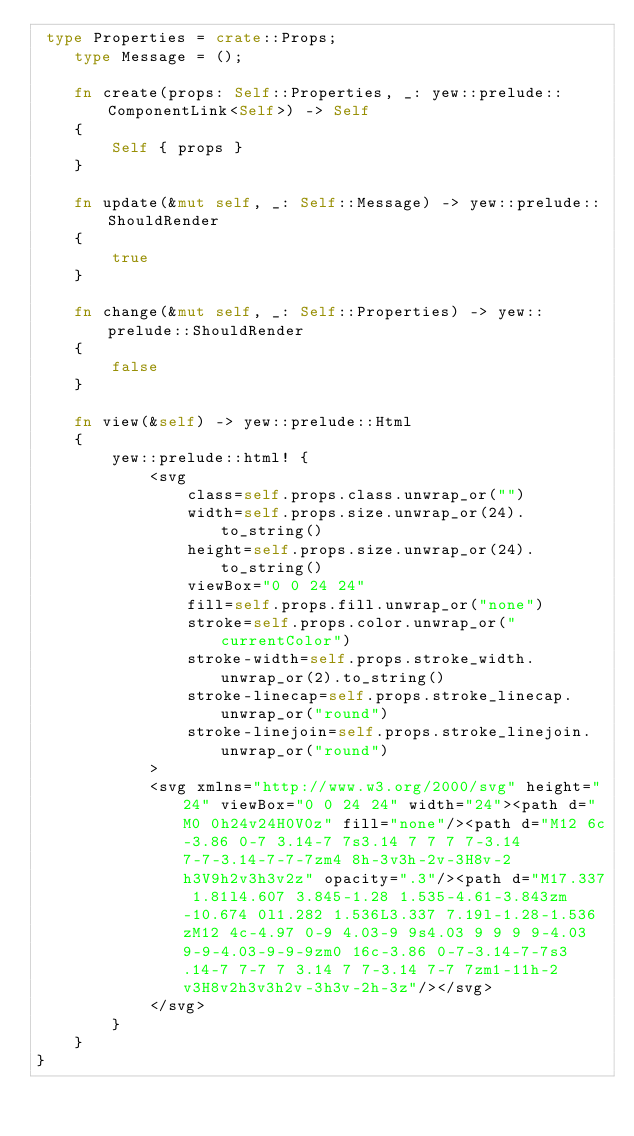Convert code to text. <code><loc_0><loc_0><loc_500><loc_500><_Rust_> type Properties = crate::Props;
    type Message = ();

    fn create(props: Self::Properties, _: yew::prelude::ComponentLink<Self>) -> Self
    {
        Self { props }
    }

    fn update(&mut self, _: Self::Message) -> yew::prelude::ShouldRender
    {
        true
    }

    fn change(&mut self, _: Self::Properties) -> yew::prelude::ShouldRender
    {
        false
    }

    fn view(&self) -> yew::prelude::Html
    {
        yew::prelude::html! {
            <svg
                class=self.props.class.unwrap_or("")
                width=self.props.size.unwrap_or(24).to_string()
                height=self.props.size.unwrap_or(24).to_string()
                viewBox="0 0 24 24"
                fill=self.props.fill.unwrap_or("none")
                stroke=self.props.color.unwrap_or("currentColor")
                stroke-width=self.props.stroke_width.unwrap_or(2).to_string()
                stroke-linecap=self.props.stroke_linecap.unwrap_or("round")
                stroke-linejoin=self.props.stroke_linejoin.unwrap_or("round")
            >
            <svg xmlns="http://www.w3.org/2000/svg" height="24" viewBox="0 0 24 24" width="24"><path d="M0 0h24v24H0V0z" fill="none"/><path d="M12 6c-3.86 0-7 3.14-7 7s3.14 7 7 7 7-3.14 7-7-3.14-7-7-7zm4 8h-3v3h-2v-3H8v-2h3V9h2v3h3v2z" opacity=".3"/><path d="M17.337 1.81l4.607 3.845-1.28 1.535-4.61-3.843zm-10.674 0l1.282 1.536L3.337 7.19l-1.28-1.536zM12 4c-4.97 0-9 4.03-9 9s4.03 9 9 9 9-4.03 9-9-4.03-9-9-9zm0 16c-3.86 0-7-3.14-7-7s3.14-7 7-7 7 3.14 7 7-3.14 7-7 7zm1-11h-2v3H8v2h3v3h2v-3h3v-2h-3z"/></svg>
            </svg>
        }
    }
}


</code> 